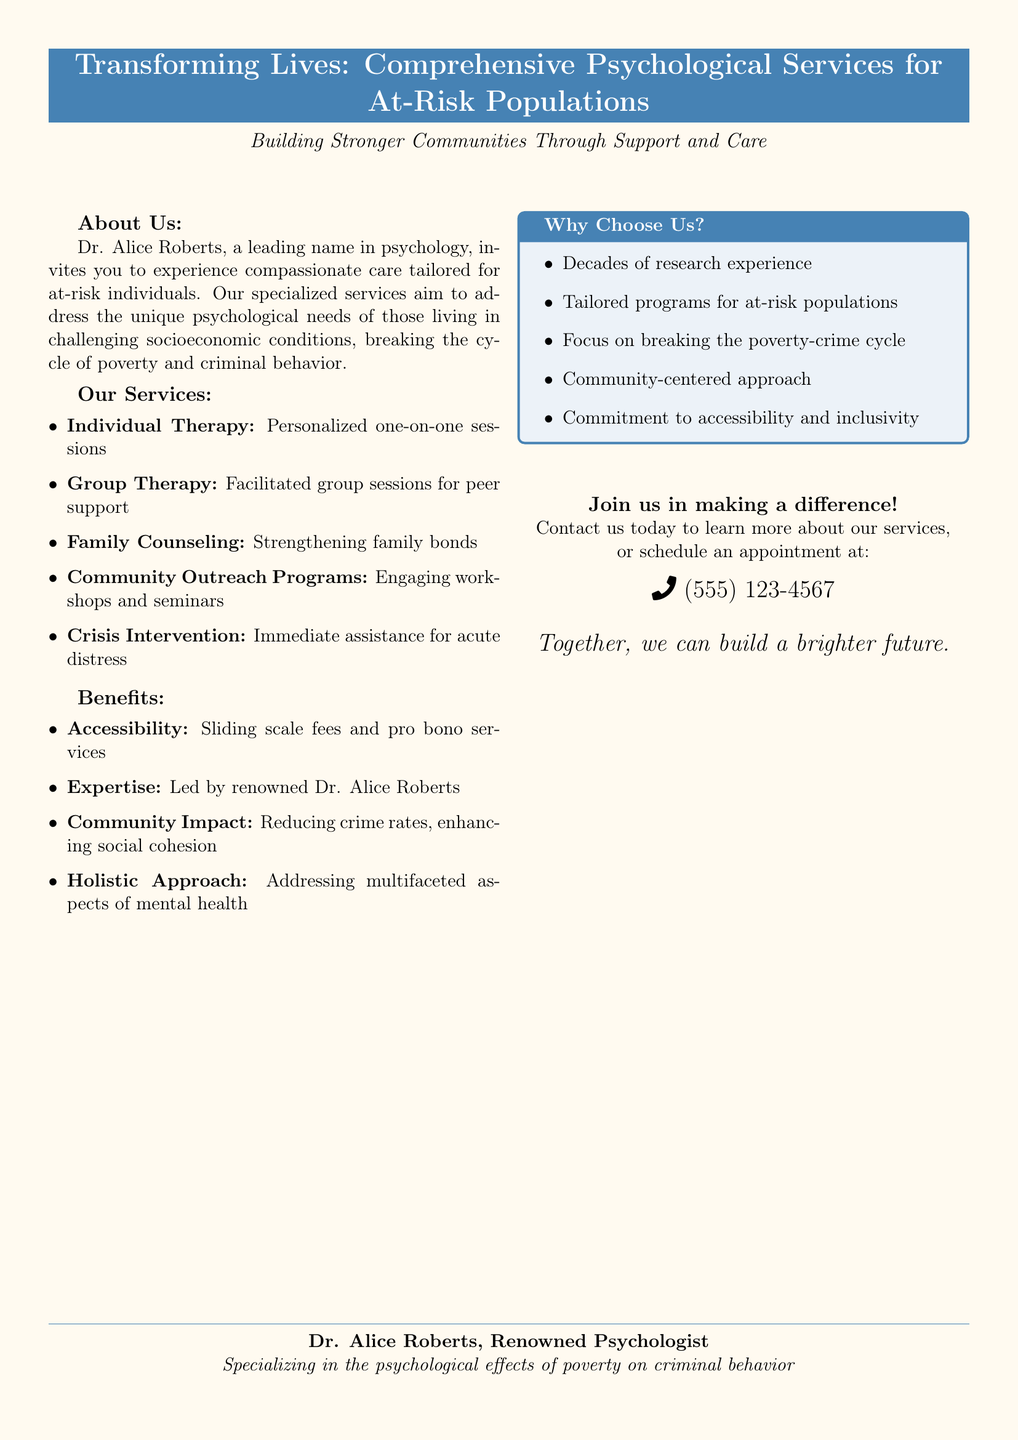What is the name of the leading psychologist? The document explicitly mentions Dr. Alice Roberts as the leading name in psychology.
Answer: Dr. Alice Roberts What type of therapy involves peer support? The document describes facilitated group sessions that offer peer support as Group Therapy.
Answer: Group Therapy What is one benefit of the psychological services offered? The document lists several benefits, one of which is Accessibility, referring to sliding scale fees and pro bono services.
Answer: Accessibility What is the main aim of the community outreach programs? The outreach programs are designed to engage individuals through workshops and seminars, contributing to their psychological well-being.
Answer: Engaging workshops and seminars How can individuals contact the clinic? The document mentions that individuals can contact the clinic by phone at the given number.
Answer: (555) 123-4567 What is the focus of the holistic approach mentioned? The holistic approach refers to addressing multifaceted aspects of mental health, which includes considering various factors affecting an individual's well-being.
Answer: Multifaceted aspects of mental health How many years of research experience does the clinic claim to have? The document states "decades of research experience," indicating a substantial amount of time dedicated to research.
Answer: Decades What is the relationship between poverty and criminal behavior as noted in the services? The document emphasizes the clinic's aim to break the cycle of poverty and criminal behavior, highlighting their research focus on this relationship.
Answer: Break the cycle of poverty and criminal behavior 